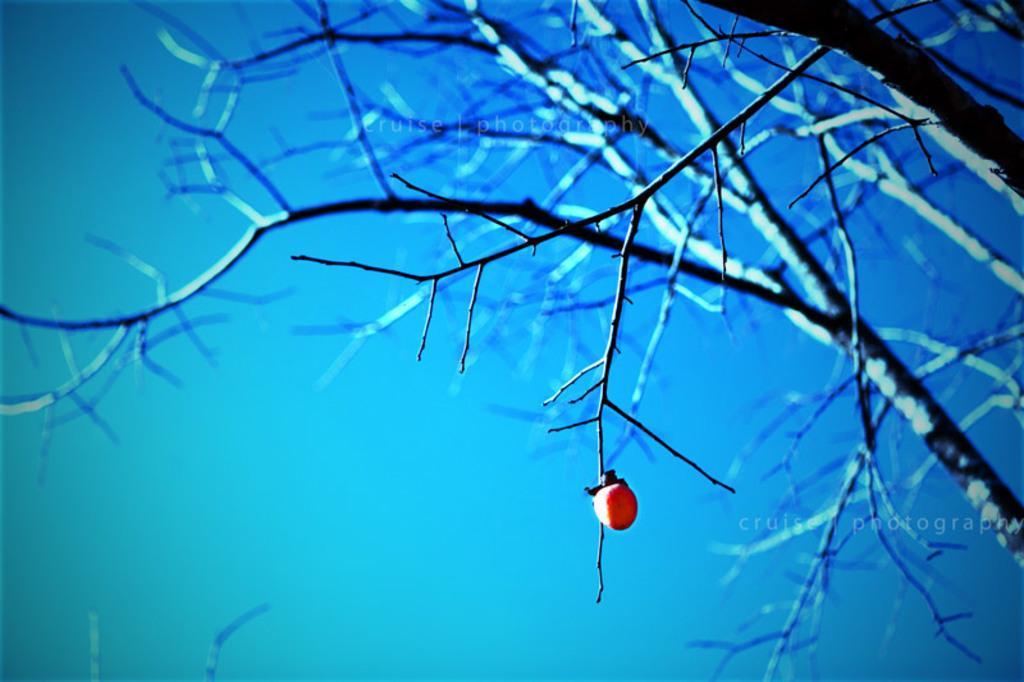In one or two sentences, can you explain what this image depicts? In this image we can see a fruit on the branch of a tree. On the backside we can see the sky. 